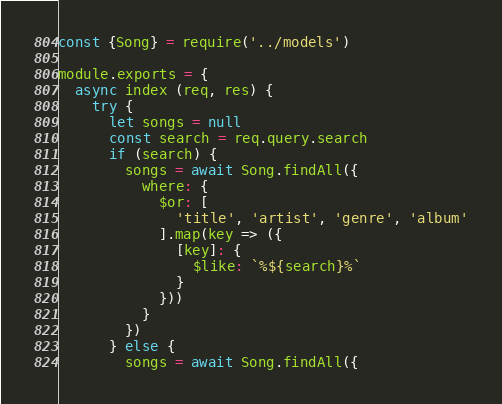Convert code to text. <code><loc_0><loc_0><loc_500><loc_500><_JavaScript_>const {Song} = require('../models')

module.exports = {
  async index (req, res) {
    try {
      let songs = null
      const search = req.query.search
      if (search) {
        songs = await Song.findAll({
          where: {
            $or: [
              'title', 'artist', 'genre', 'album'
            ].map(key => ({
              [key]: {
                $like: `%${search}%`
              }
            }))
          }
        })
      } else {
        songs = await Song.findAll({</code> 